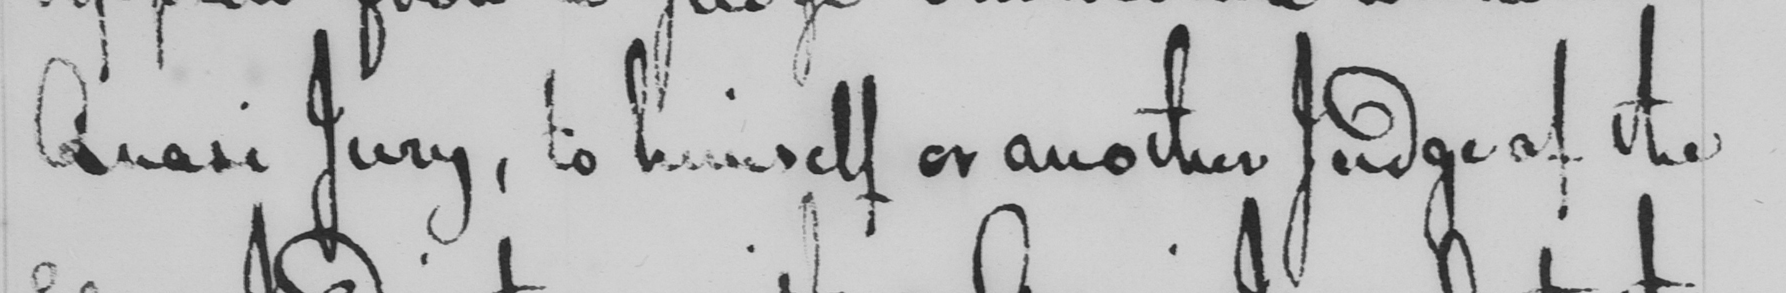Please provide the text content of this handwritten line. Quasi Jury , to himself or another Judge of the 